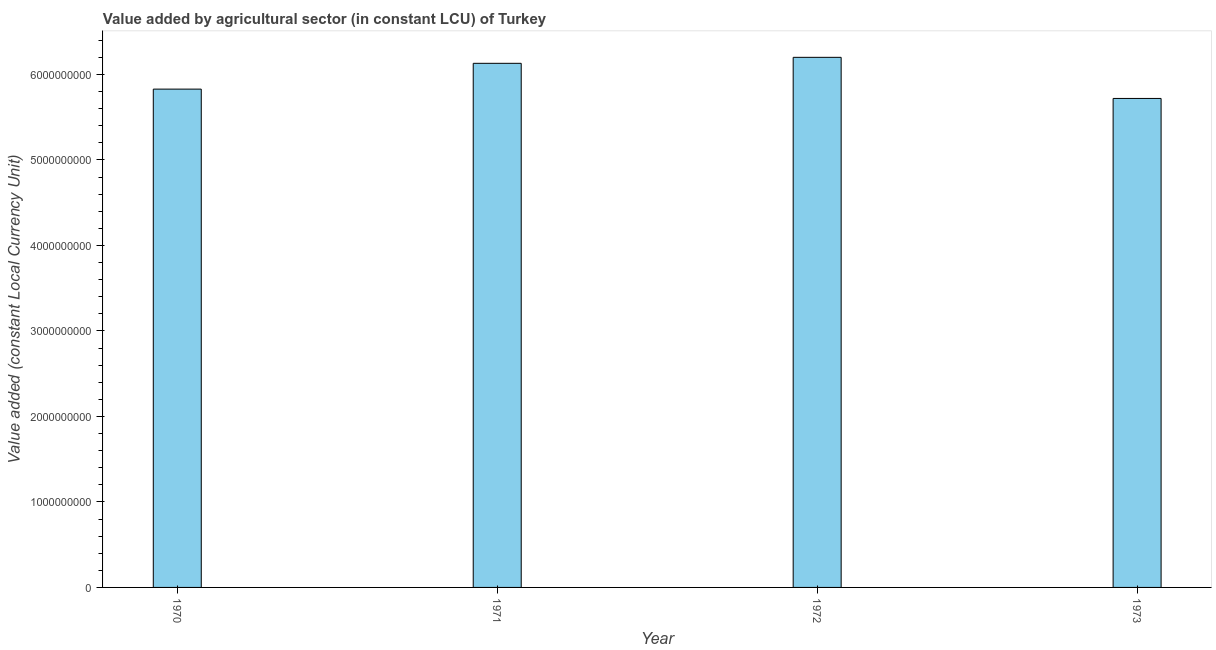Does the graph contain any zero values?
Your answer should be compact. No. Does the graph contain grids?
Give a very brief answer. No. What is the title of the graph?
Provide a short and direct response. Value added by agricultural sector (in constant LCU) of Turkey. What is the label or title of the X-axis?
Ensure brevity in your answer.  Year. What is the label or title of the Y-axis?
Offer a terse response. Value added (constant Local Currency Unit). What is the value added by agriculture sector in 1972?
Your answer should be compact. 6.20e+09. Across all years, what is the maximum value added by agriculture sector?
Your response must be concise. 6.20e+09. Across all years, what is the minimum value added by agriculture sector?
Your response must be concise. 5.72e+09. In which year was the value added by agriculture sector minimum?
Provide a succinct answer. 1973. What is the sum of the value added by agriculture sector?
Provide a short and direct response. 2.39e+1. What is the difference between the value added by agriculture sector in 1971 and 1972?
Ensure brevity in your answer.  -7.02e+07. What is the average value added by agriculture sector per year?
Your answer should be compact. 5.97e+09. What is the median value added by agriculture sector?
Offer a very short reply. 5.98e+09. In how many years, is the value added by agriculture sector greater than 1400000000 LCU?
Make the answer very short. 4. Do a majority of the years between 1973 and 1971 (inclusive) have value added by agriculture sector greater than 1800000000 LCU?
Provide a short and direct response. Yes. What is the ratio of the value added by agriculture sector in 1970 to that in 1973?
Your answer should be very brief. 1.02. Is the value added by agriculture sector in 1970 less than that in 1972?
Offer a terse response. Yes. What is the difference between the highest and the second highest value added by agriculture sector?
Your response must be concise. 7.02e+07. Is the sum of the value added by agriculture sector in 1970 and 1971 greater than the maximum value added by agriculture sector across all years?
Keep it short and to the point. Yes. What is the difference between the highest and the lowest value added by agriculture sector?
Your answer should be very brief. 4.81e+08. Are all the bars in the graph horizontal?
Your answer should be very brief. No. How many years are there in the graph?
Make the answer very short. 4. Are the values on the major ticks of Y-axis written in scientific E-notation?
Your response must be concise. No. What is the Value added (constant Local Currency Unit) in 1970?
Provide a short and direct response. 5.83e+09. What is the Value added (constant Local Currency Unit) of 1971?
Provide a succinct answer. 6.13e+09. What is the Value added (constant Local Currency Unit) of 1972?
Your response must be concise. 6.20e+09. What is the Value added (constant Local Currency Unit) in 1973?
Your response must be concise. 5.72e+09. What is the difference between the Value added (constant Local Currency Unit) in 1970 and 1971?
Make the answer very short. -3.02e+08. What is the difference between the Value added (constant Local Currency Unit) in 1970 and 1972?
Provide a succinct answer. -3.72e+08. What is the difference between the Value added (constant Local Currency Unit) in 1970 and 1973?
Give a very brief answer. 1.09e+08. What is the difference between the Value added (constant Local Currency Unit) in 1971 and 1972?
Offer a very short reply. -7.02e+07. What is the difference between the Value added (constant Local Currency Unit) in 1971 and 1973?
Your answer should be very brief. 4.11e+08. What is the difference between the Value added (constant Local Currency Unit) in 1972 and 1973?
Make the answer very short. 4.81e+08. What is the ratio of the Value added (constant Local Currency Unit) in 1970 to that in 1971?
Provide a succinct answer. 0.95. What is the ratio of the Value added (constant Local Currency Unit) in 1970 to that in 1972?
Your answer should be compact. 0.94. What is the ratio of the Value added (constant Local Currency Unit) in 1970 to that in 1973?
Provide a short and direct response. 1.02. What is the ratio of the Value added (constant Local Currency Unit) in 1971 to that in 1973?
Keep it short and to the point. 1.07. What is the ratio of the Value added (constant Local Currency Unit) in 1972 to that in 1973?
Your response must be concise. 1.08. 